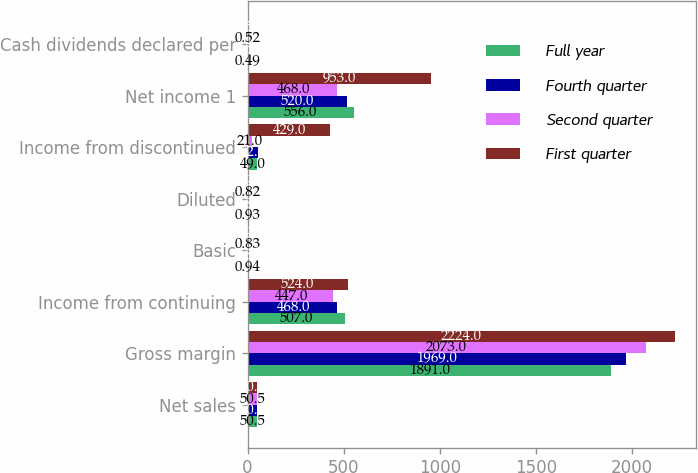Convert chart to OTSL. <chart><loc_0><loc_0><loc_500><loc_500><stacked_bar_chart><ecel><fcel>Net sales<fcel>Gross margin<fcel>Income from continuing<fcel>Basic<fcel>Diluted<fcel>Income from discontinued<fcel>Net income 1<fcel>Cash dividends declared per<nl><fcel>Full year<fcel>50.5<fcel>1891<fcel>507<fcel>0.94<fcel>0.93<fcel>49<fcel>556<fcel>0.49<nl><fcel>Fourth quarter<fcel>50.5<fcel>1969<fcel>468<fcel>0.86<fcel>0.85<fcel>52<fcel>520<fcel>0.52<nl><fcel>Second quarter<fcel>50.5<fcel>2073<fcel>447<fcel>0.83<fcel>0.82<fcel>21<fcel>468<fcel>0.52<nl><fcel>First quarter<fcel>50.5<fcel>2224<fcel>524<fcel>0.97<fcel>0.96<fcel>429<fcel>953<fcel>0.52<nl></chart> 